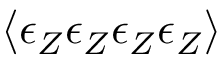<formula> <loc_0><loc_0><loc_500><loc_500>\langle \epsilon _ { Z } \epsilon _ { Z } \epsilon _ { Z } \epsilon _ { Z } \rangle</formula> 